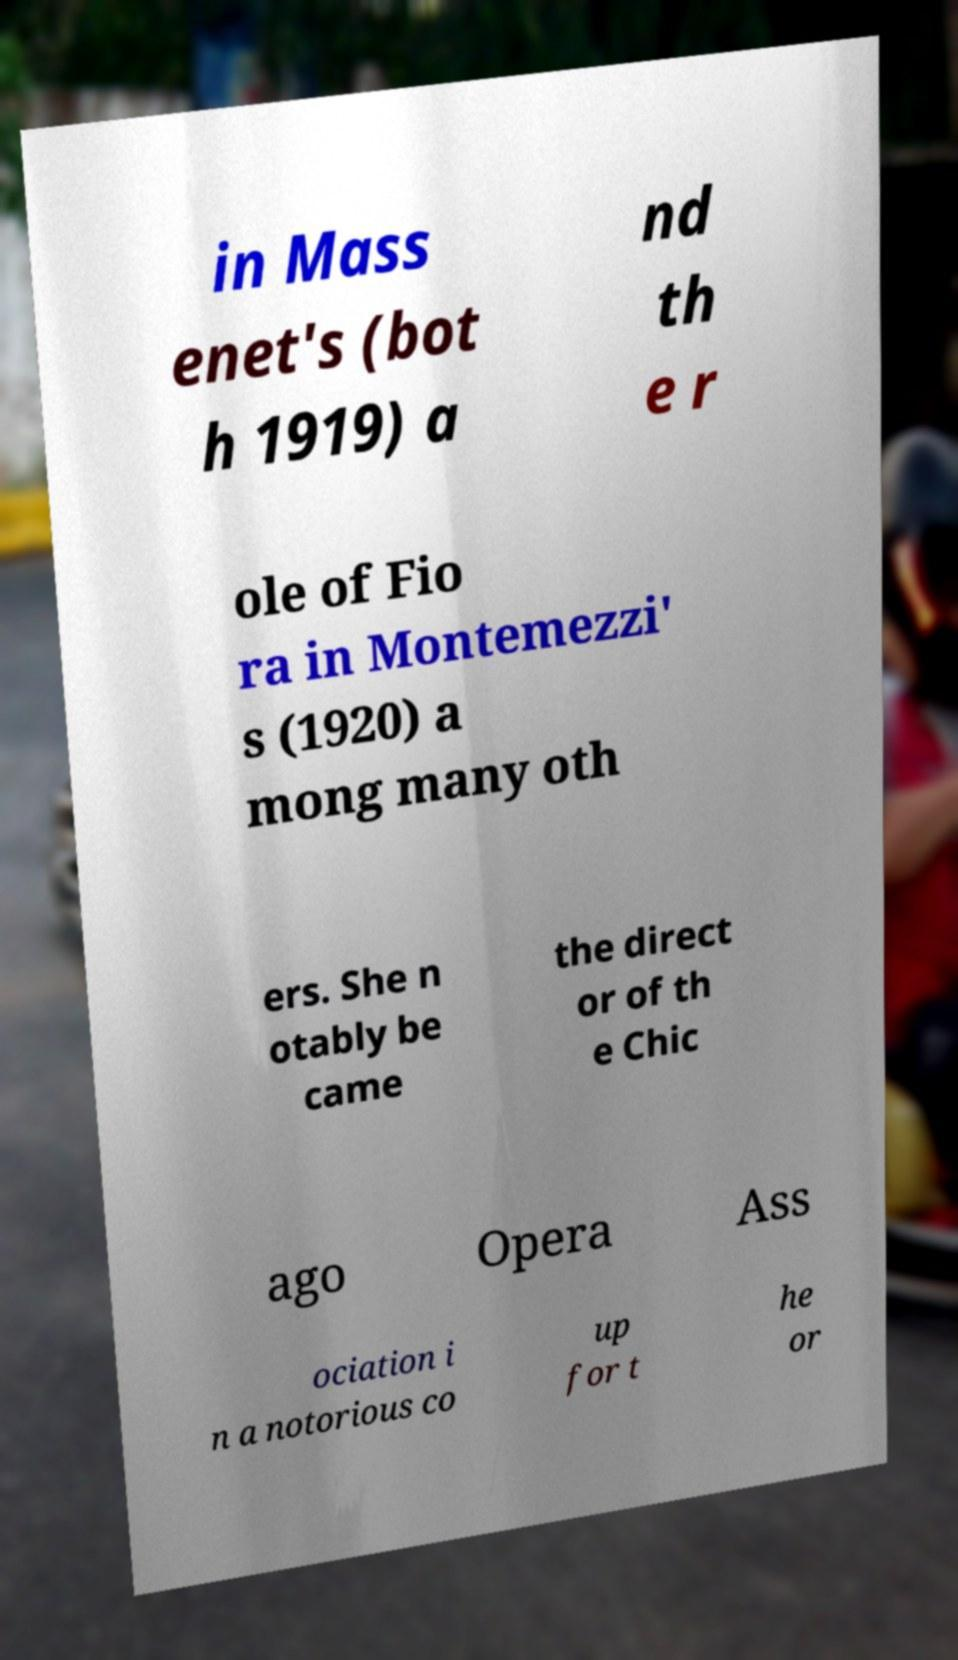For documentation purposes, I need the text within this image transcribed. Could you provide that? in Mass enet's (bot h 1919) a nd th e r ole of Fio ra in Montemezzi' s (1920) a mong many oth ers. She n otably be came the direct or of th e Chic ago Opera Ass ociation i n a notorious co up for t he or 